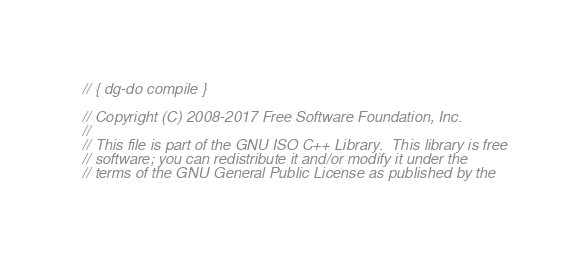<code> <loc_0><loc_0><loc_500><loc_500><_C++_>// { dg-do compile }

// Copyright (C) 2008-2017 Free Software Foundation, Inc.
//
// This file is part of the GNU ISO C++ Library.  This library is free
// software; you can redistribute it and/or modify it under the
// terms of the GNU General Public License as published by the</code> 